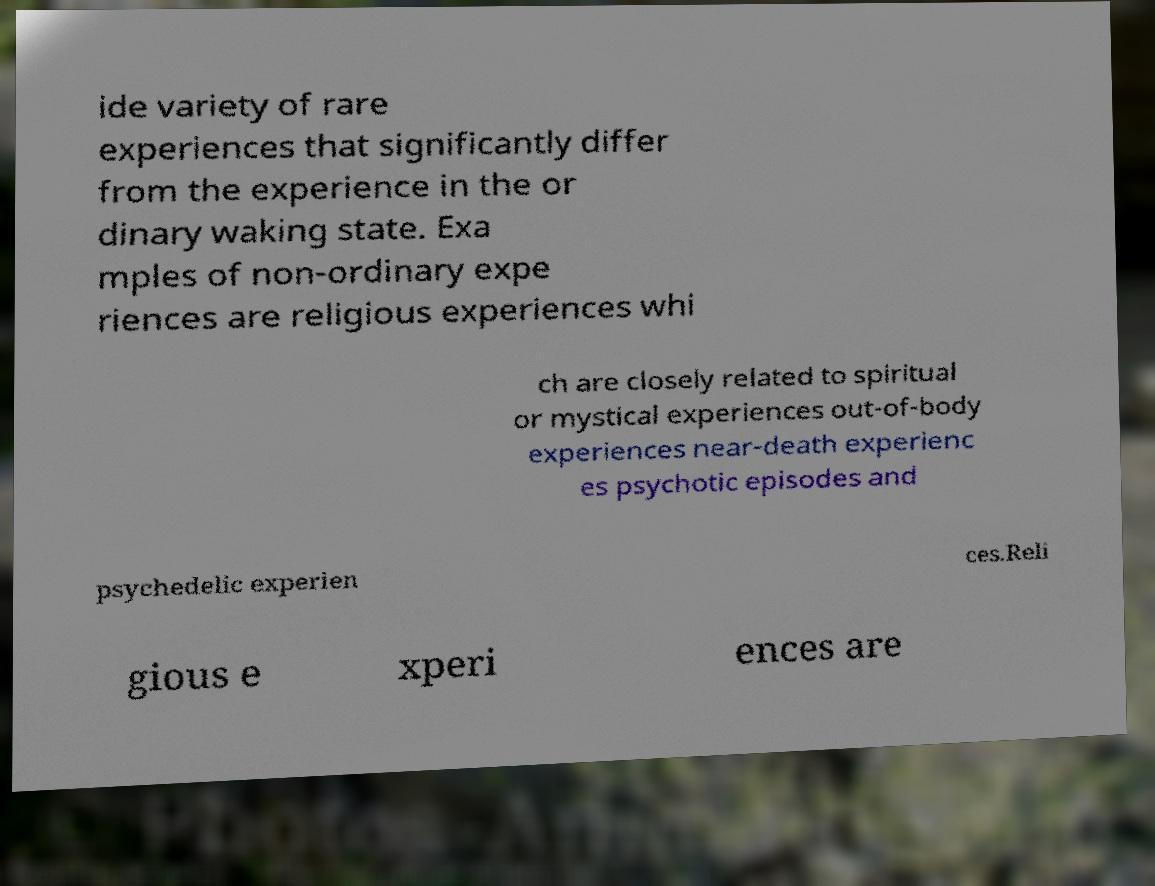There's text embedded in this image that I need extracted. Can you transcribe it verbatim? ide variety of rare experiences that significantly differ from the experience in the or dinary waking state. Exa mples of non-ordinary expe riences are religious experiences whi ch are closely related to spiritual or mystical experiences out-of-body experiences near-death experienc es psychotic episodes and psychedelic experien ces.Reli gious e xperi ences are 